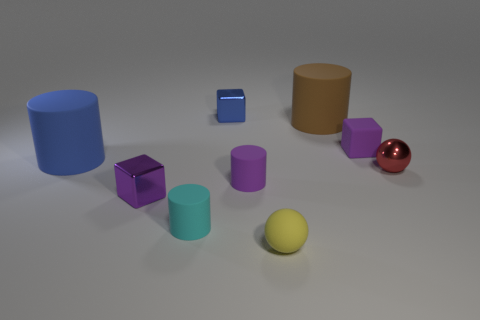Add 1 blue blocks. How many objects exist? 10 Subtract all cylinders. How many objects are left? 5 Add 1 red matte cylinders. How many red matte cylinders exist? 1 Subtract 0 yellow blocks. How many objects are left? 9 Subtract all cyan metallic objects. Subtract all yellow rubber spheres. How many objects are left? 8 Add 4 small cylinders. How many small cylinders are left? 6 